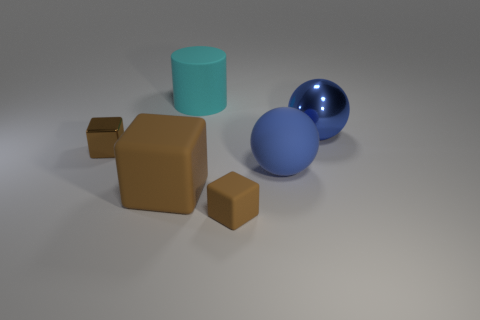Are there more tiny metallic objects that are to the right of the cylinder than large brown things?
Give a very brief answer. No. What material is the large sphere in front of the big blue shiny object?
Provide a short and direct response. Rubber. What color is the tiny metallic thing that is the same shape as the big brown thing?
Keep it short and to the point. Brown. How many big cylinders are the same color as the large metallic ball?
Your answer should be very brief. 0. There is a matte block that is right of the big brown rubber cube; does it have the same size as the blue object that is behind the big blue matte sphere?
Provide a short and direct response. No. Does the blue rubber sphere have the same size as the metallic thing to the left of the large brown block?
Your answer should be compact. No. What is the size of the metallic sphere?
Provide a succinct answer. Large. What color is the big cylinder that is the same material as the big block?
Keep it short and to the point. Cyan. How many cyan things have the same material as the large cylinder?
Keep it short and to the point. 0. How many objects are either gray metal things or small blocks that are behind the big brown rubber object?
Your response must be concise. 1. 